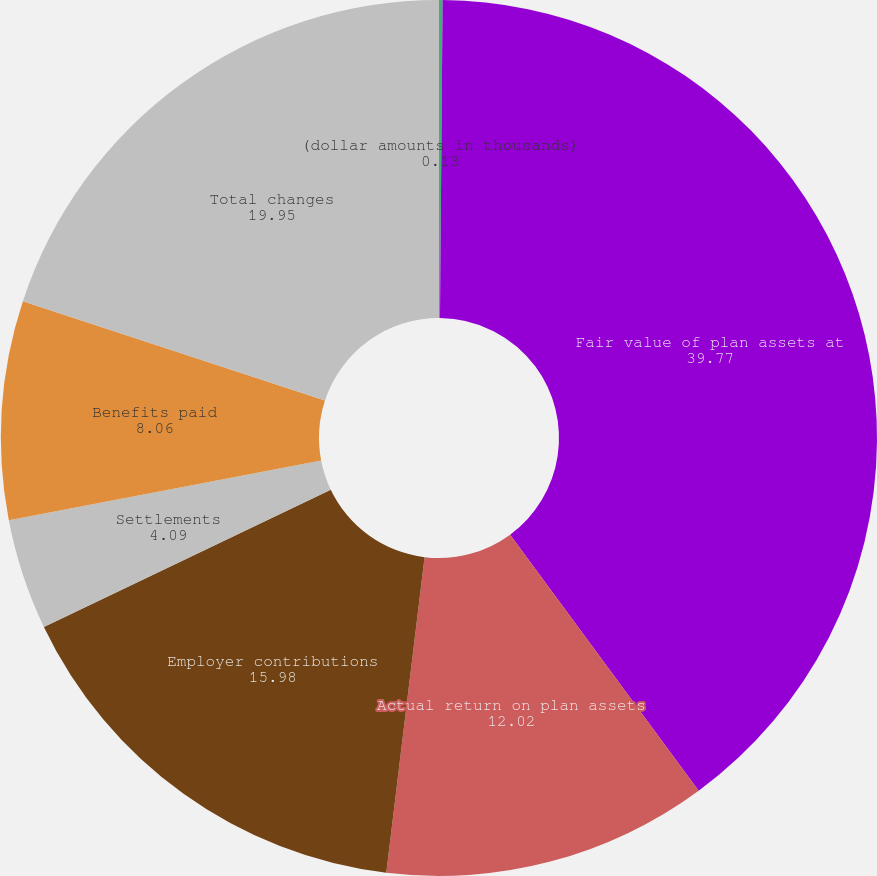Convert chart to OTSL. <chart><loc_0><loc_0><loc_500><loc_500><pie_chart><fcel>(dollar amounts in thousands)<fcel>Fair value of plan assets at<fcel>Actual return on plan assets<fcel>Employer contributions<fcel>Settlements<fcel>Benefits paid<fcel>Total changes<nl><fcel>0.13%<fcel>39.77%<fcel>12.02%<fcel>15.98%<fcel>4.09%<fcel>8.06%<fcel>19.95%<nl></chart> 